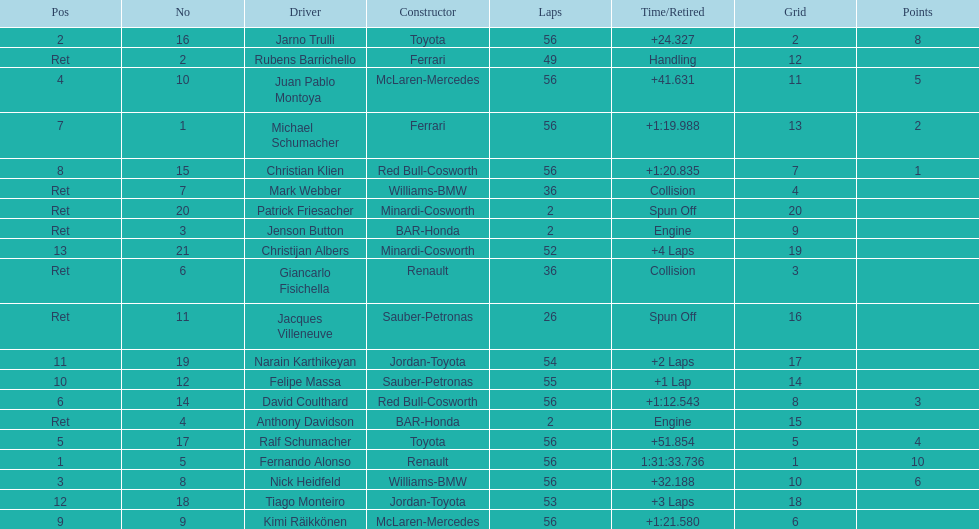How many drivers were retired before the race could end? 7. 